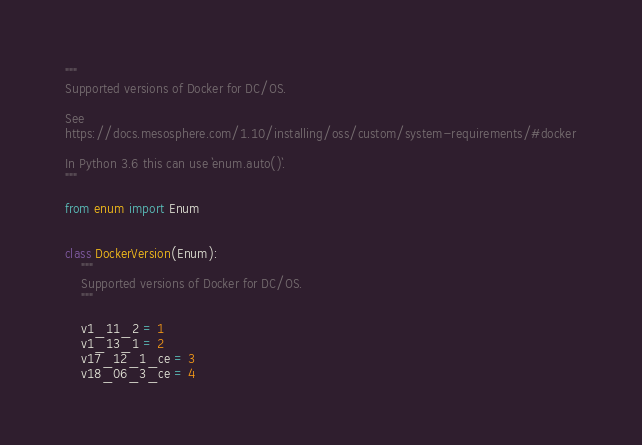<code> <loc_0><loc_0><loc_500><loc_500><_Python_>"""
Supported versions of Docker for DC/OS.

See
https://docs.mesosphere.com/1.10/installing/oss/custom/system-requirements/#docker

In Python 3.6 this can use `enum.auto()`.
"""

from enum import Enum


class DockerVersion(Enum):
    """
    Supported versions of Docker for DC/OS.
    """

    v1_11_2 = 1
    v1_13_1 = 2
    v17_12_1_ce = 3
    v18_06_3_ce = 4
</code> 